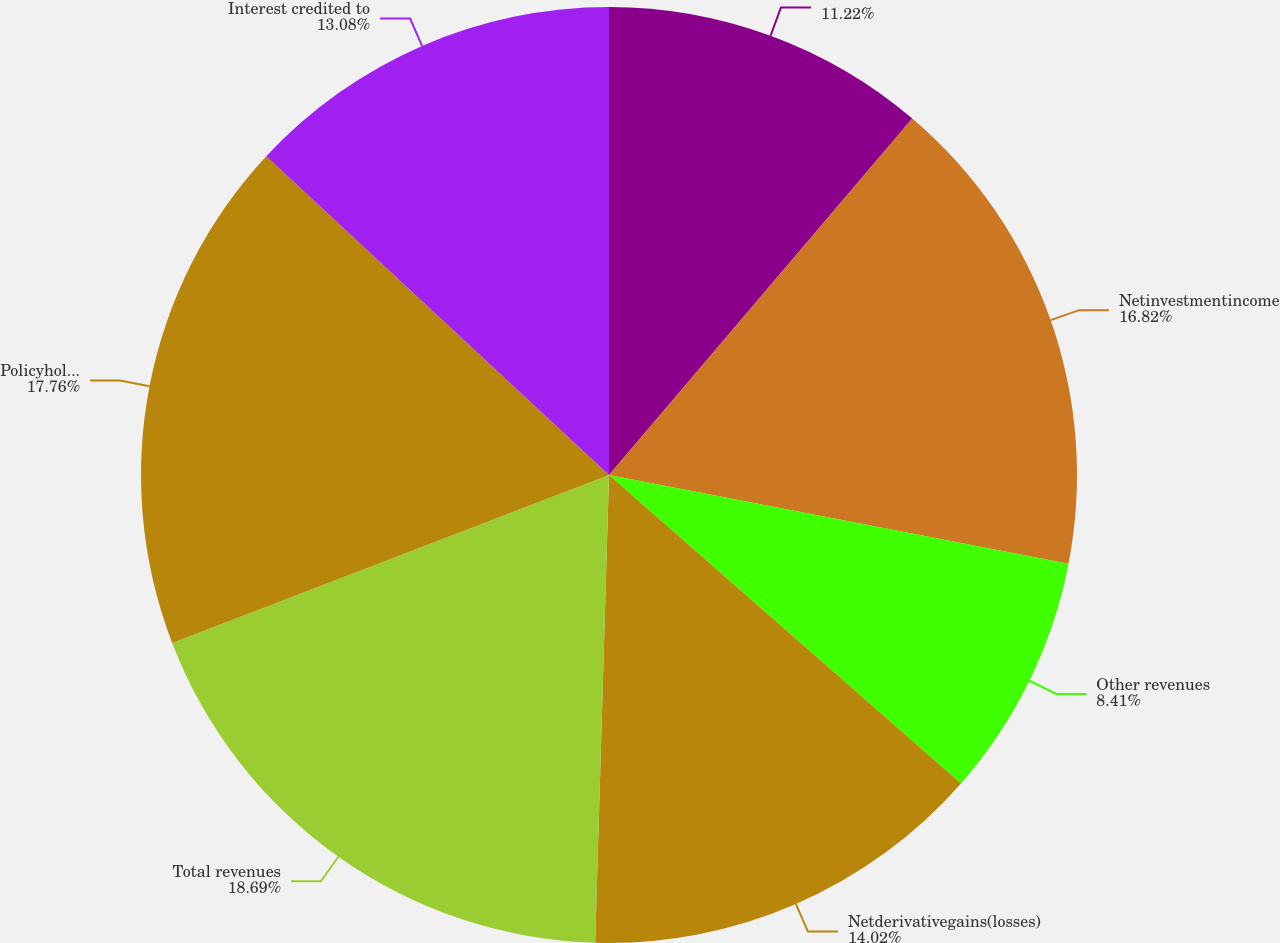Convert chart. <chart><loc_0><loc_0><loc_500><loc_500><pie_chart><ecel><fcel>Netinvestmentincome<fcel>Other revenues<fcel>Netderivativegains(losses)<fcel>Total revenues<fcel>Policyholder benefits and<fcel>Interest credited to<nl><fcel>11.22%<fcel>16.82%<fcel>8.41%<fcel>14.02%<fcel>18.69%<fcel>17.76%<fcel>13.08%<nl></chart> 